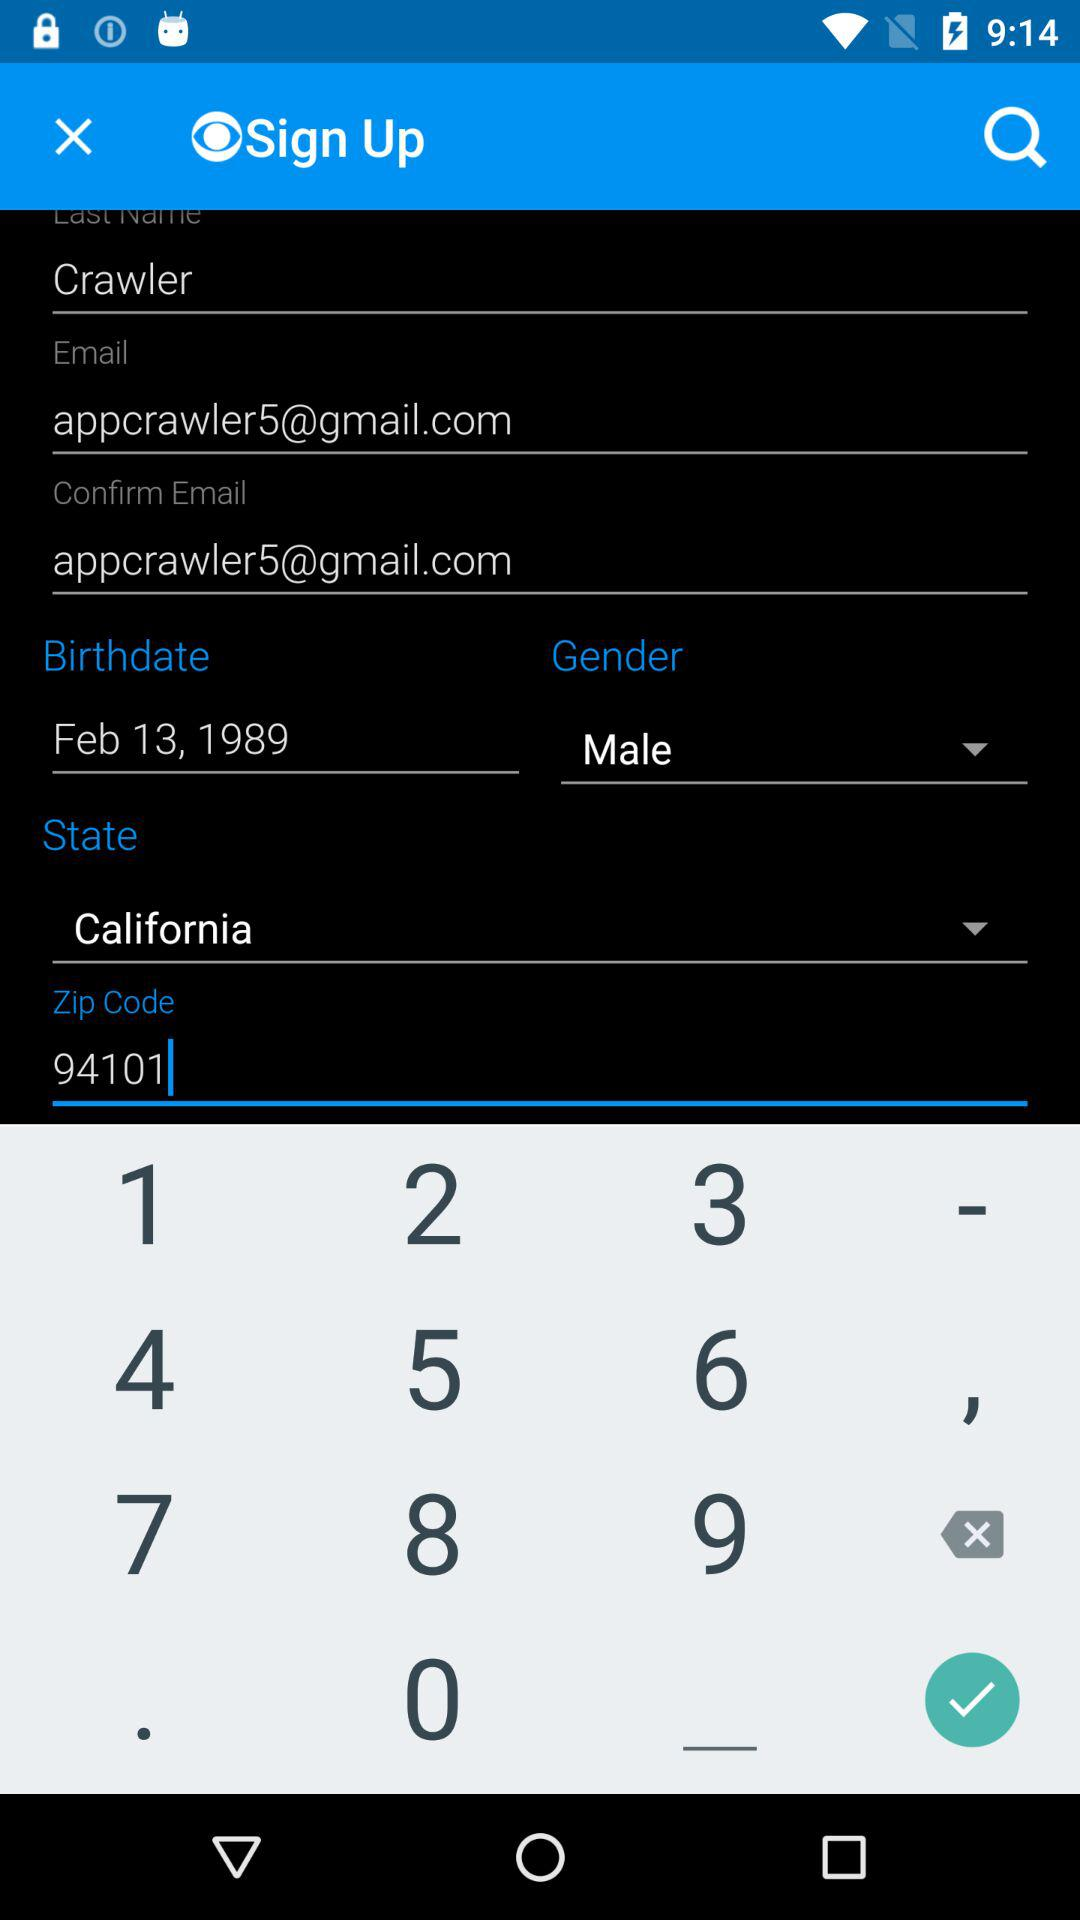What is the email address? The email address is appcrawler5@gmail.com. 